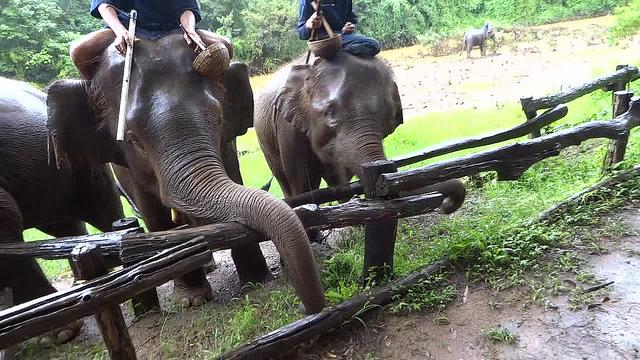Are people riding the elephants?
Concise answer only. Yes. What are the animals?
Concise answer only. Elephants. What does the person on the left have in his or her hand?
Concise answer only. Stick. 